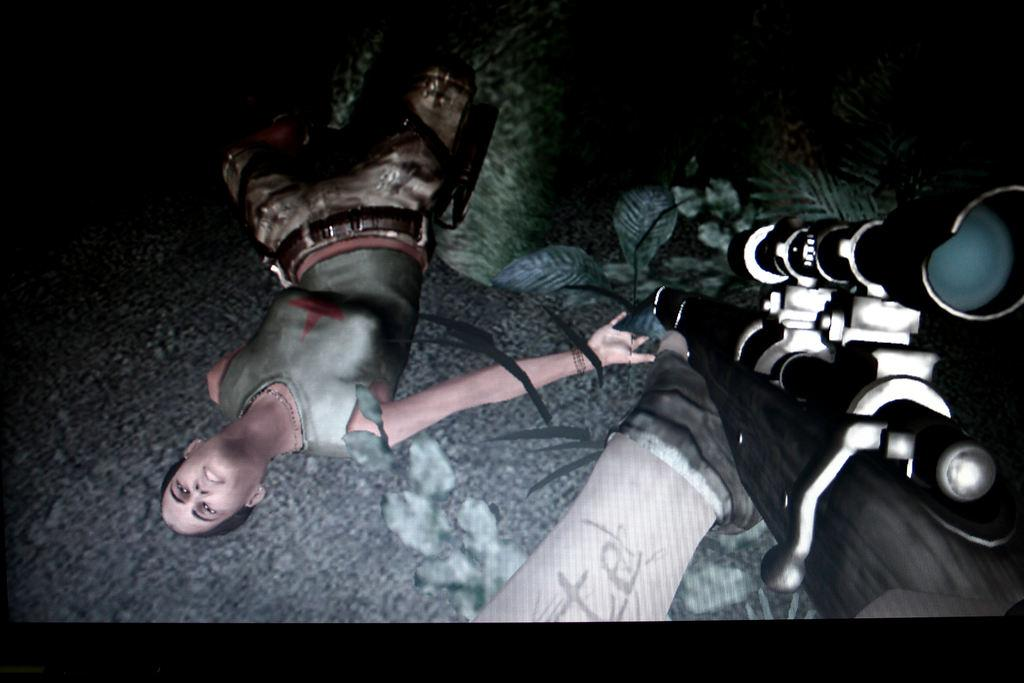What type of image is this? The image is animated. What is the woman in the image doing? The woman is lying on the ground. What type of vegetation can be seen in the image? There are plants and grass in the image. Can you describe the presence of a weapon in the image? A person's hand holding a gun is visible in the image. What type of celery is the queen holding in the image? There is no queen or celery present in the image. What type of flag is visible in the image? There is no flag visible in the image. 